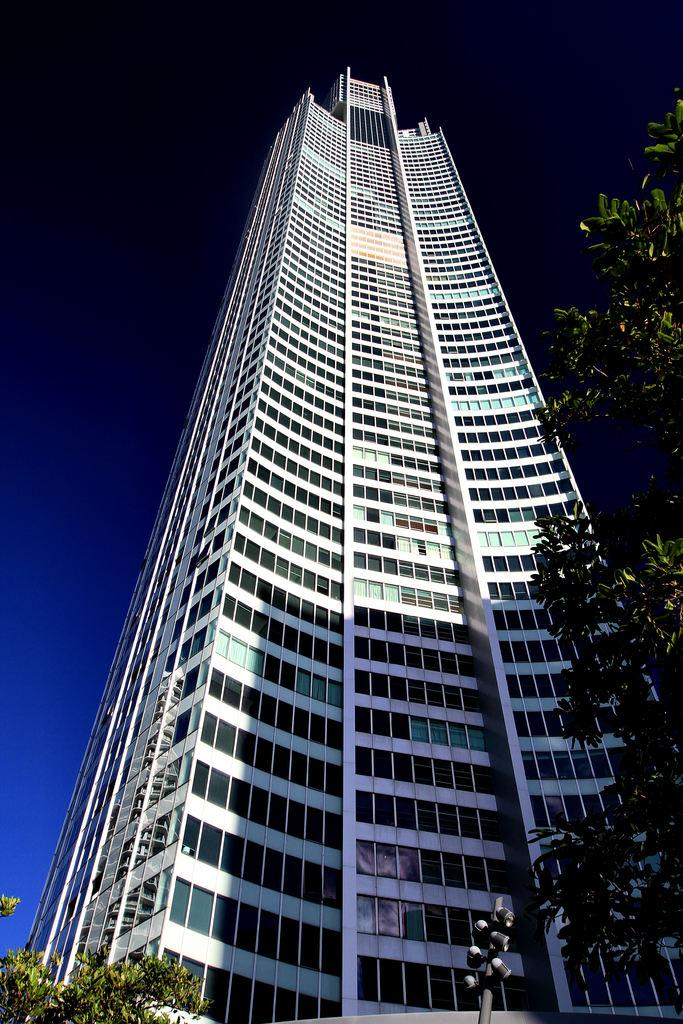What type of vegetation can be seen on the right side of the image? There is a tree on the right side of the image. What type of vegetation can be seen on the left side of the image? There is a tree on the left side of the image. What is located in the center of the image? There is a pole in the center of the image. What type of structure is in the middle of the image? There is a skyscraper in the middle of the image. What is visible in the background of the image? The sky is visible in the background of the image. Where is the cactus located in the image? There is no cactus present in the image. How does the skyscraper move around in the image? The skyscraper does not move around in the image; it is stationary. 